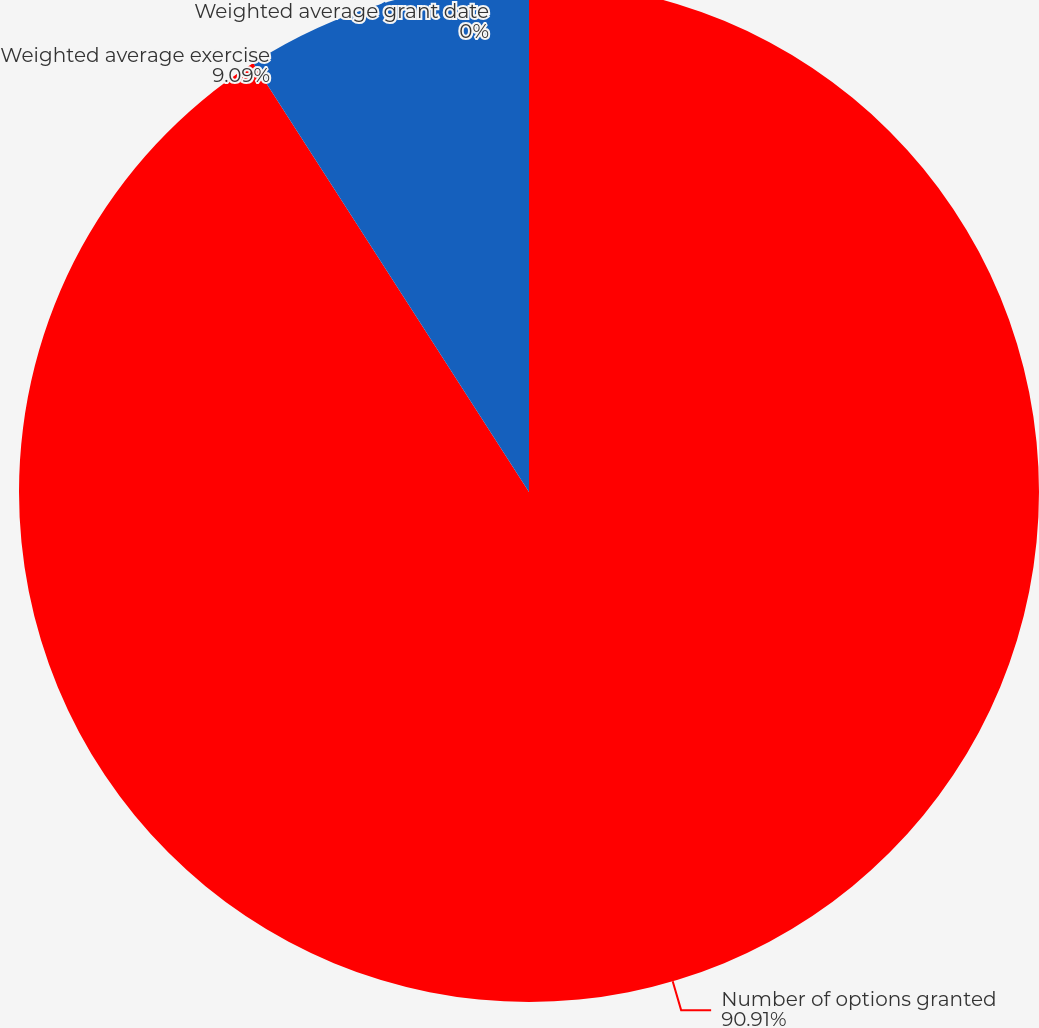<chart> <loc_0><loc_0><loc_500><loc_500><pie_chart><fcel>Number of options granted<fcel>Weighted average exercise<fcel>Weighted average grant date<nl><fcel>90.9%<fcel>9.09%<fcel>0.0%<nl></chart> 